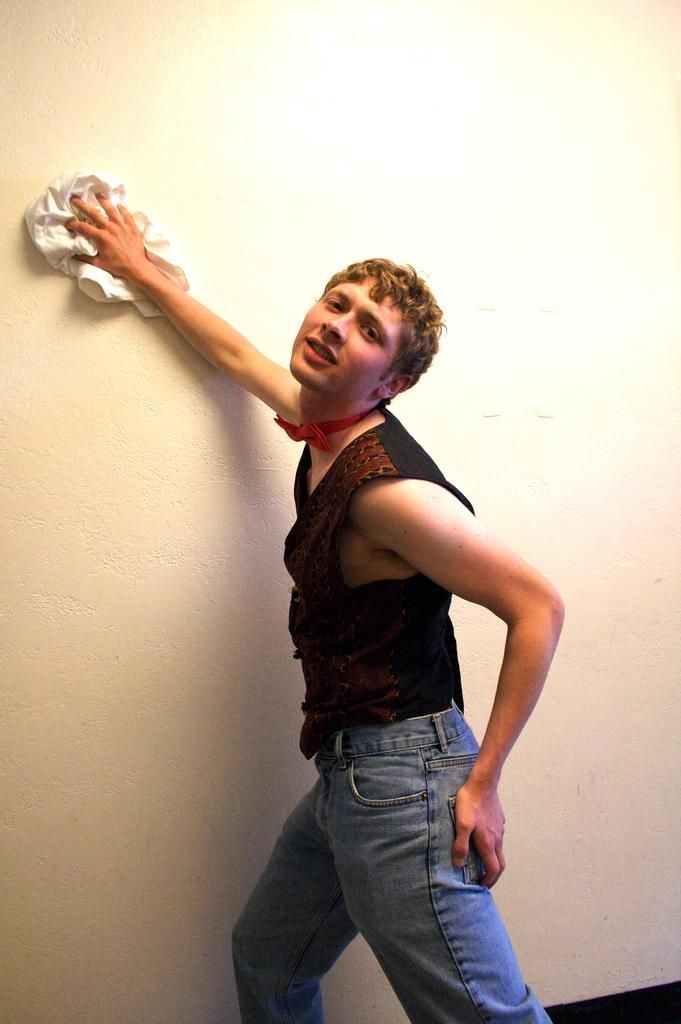What is the main subject of the image? There is a man standing in the middle of the image. What is the man holding in the image? The man is holding a cloth. What can be seen in the background of the image? There is a wall beside the man. What type of jeans is the man wearing in the image? The image does not provide information about the man's jeans, so it cannot be determined from the image. 